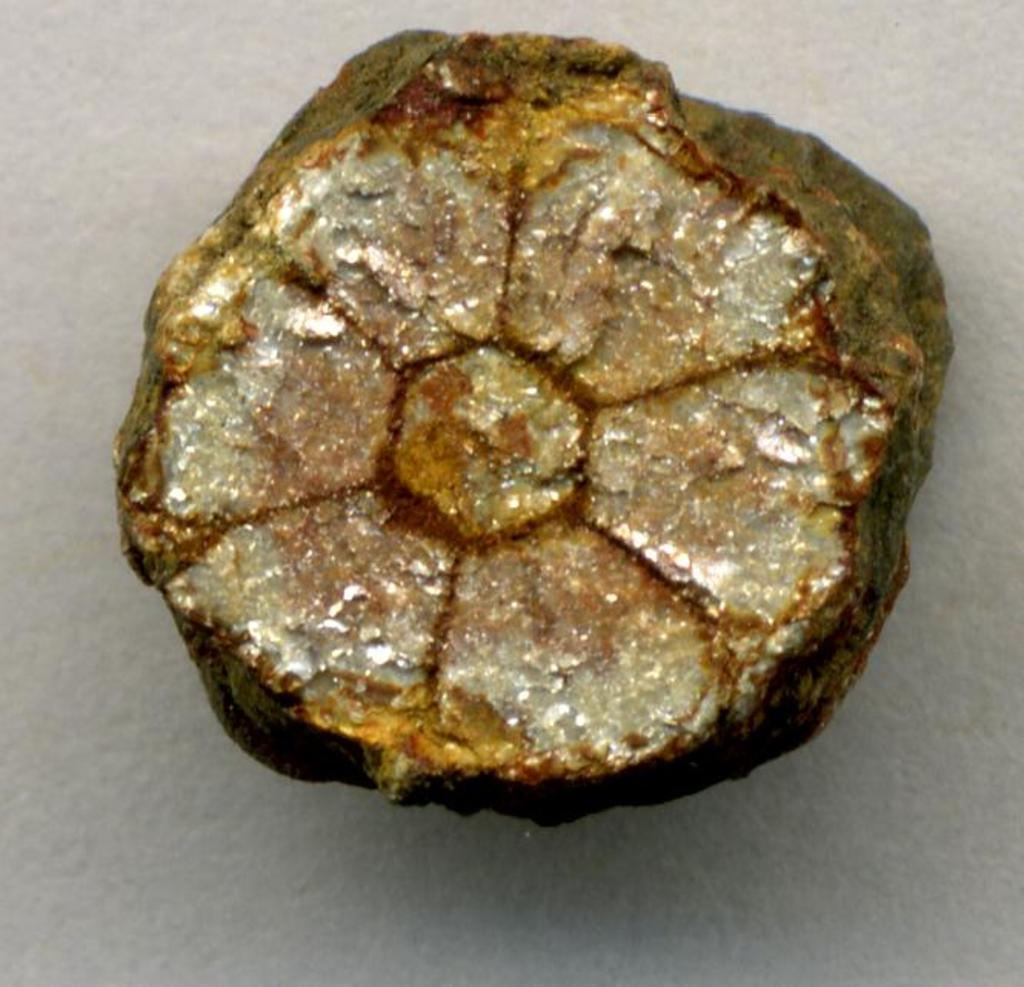What is the main subject of the image? The main subject of the image is a rock. What is the rock placed on in the image? The rock is on a white surface. How many tickets are attached to the rock in the image? There are no tickets present in the image; it only features a rock on a white surface. What type of grip does the rock have in the image? The rock does not have a grip, as it is an inanimate object. 